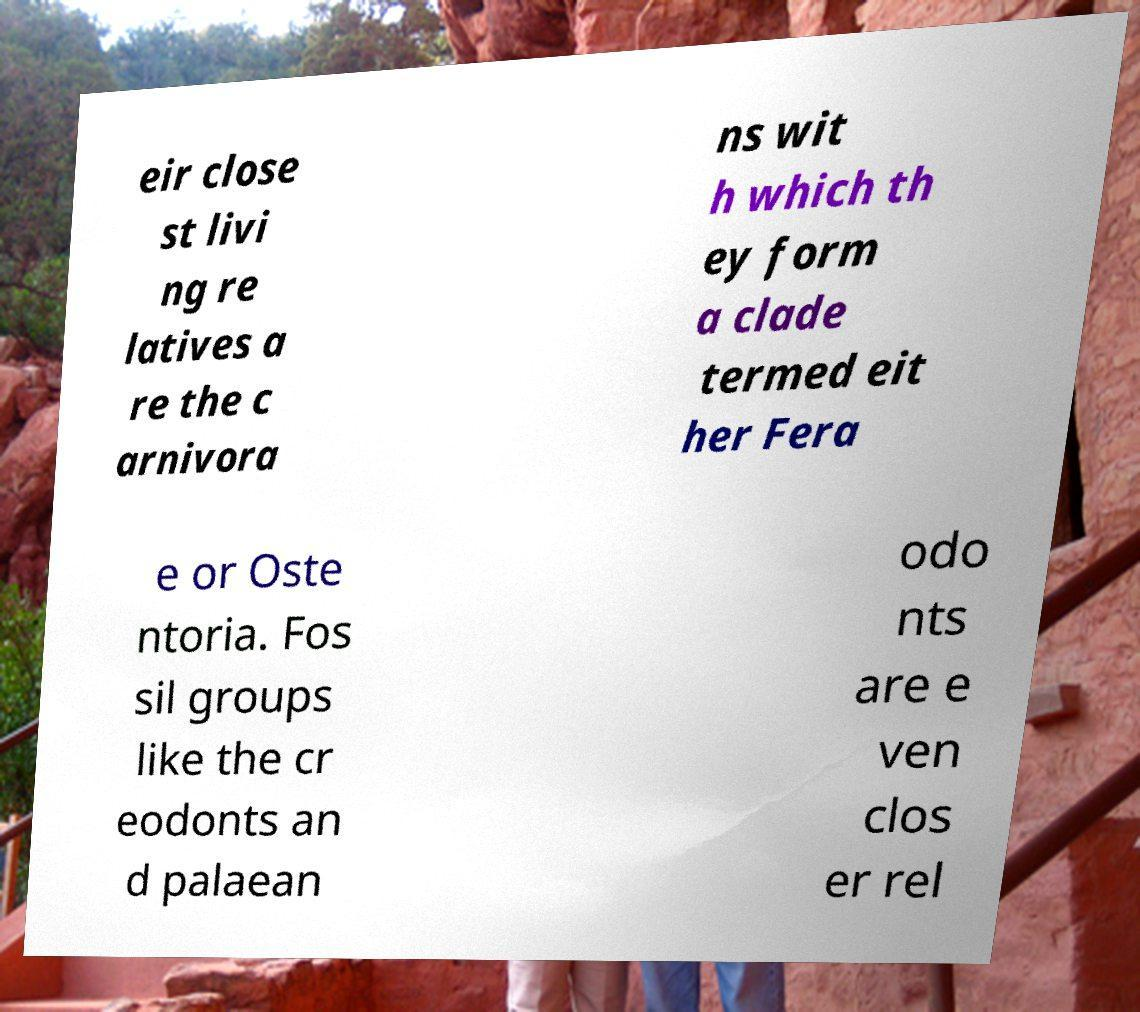What messages or text are displayed in this image? I need them in a readable, typed format. eir close st livi ng re latives a re the c arnivora ns wit h which th ey form a clade termed eit her Fera e or Oste ntoria. Fos sil groups like the cr eodonts an d palaean odo nts are e ven clos er rel 